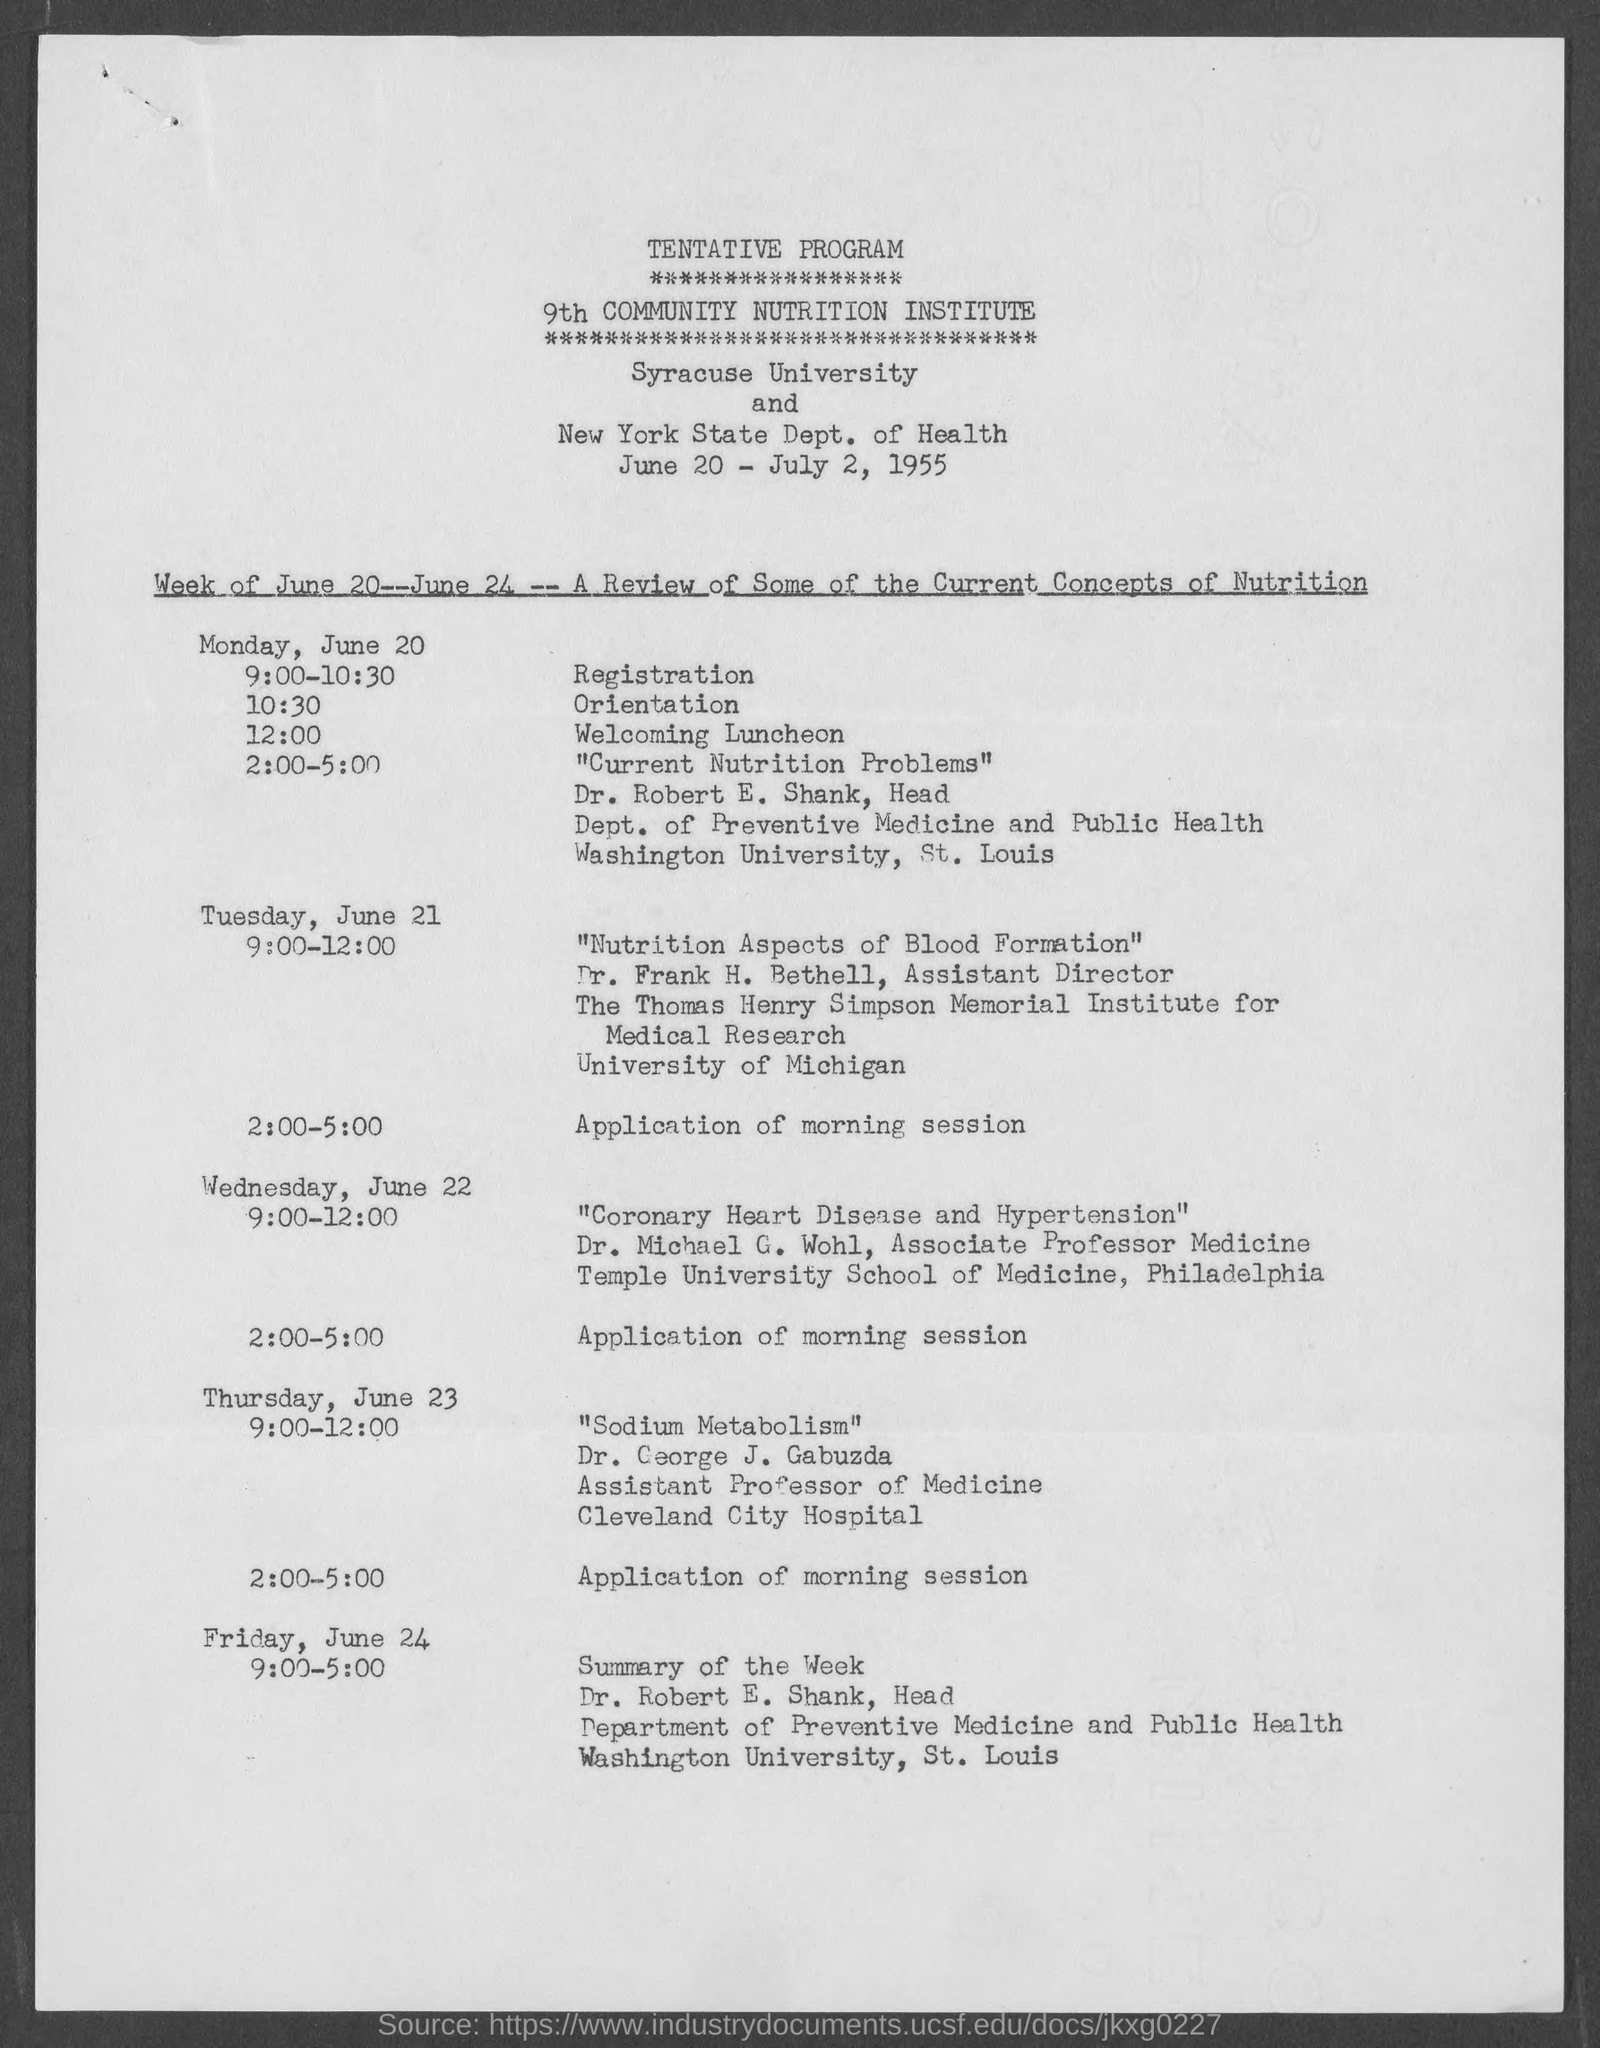List a handful of essential elements in this visual. At 9:00 - 10:30 on Monday, June 20, registration will take place. At 12:00 on Monday, June 20, the schedule was "WELCOMING LUNCHEON. Dr. Frank H. Bethell holds the designation of assistant director. Dr. Robert E. Shank belongs to the Department of Preventive Medicine and Public Health. At 10:30 on Monday, June 20, the given schedule will be in effect. 